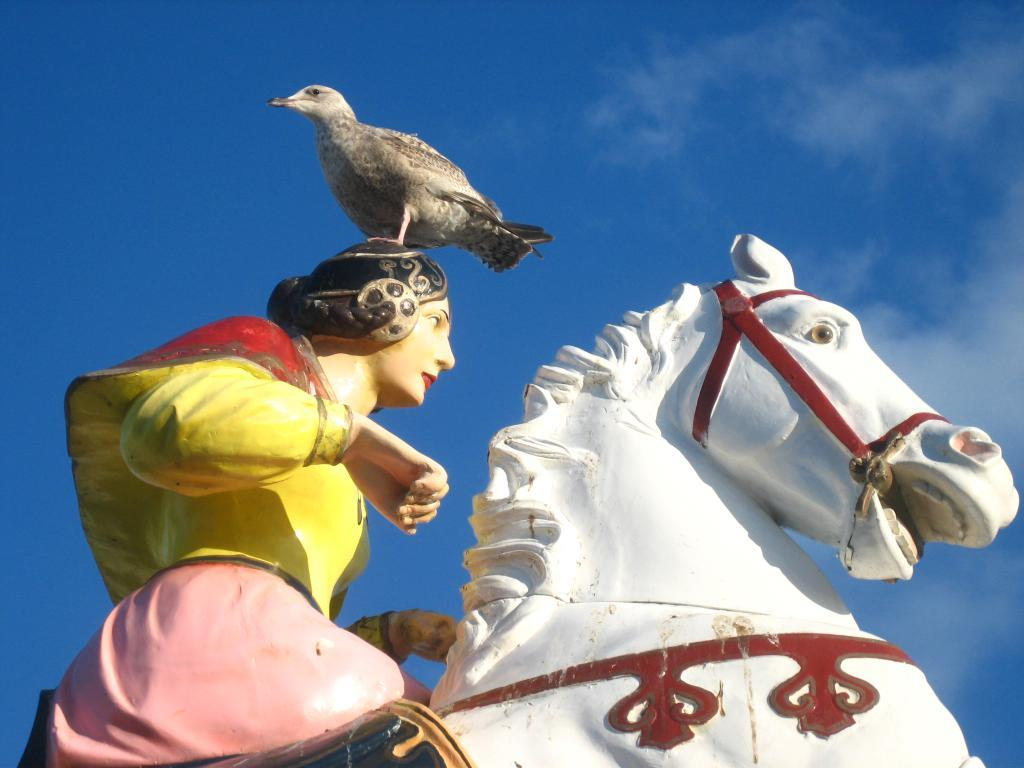What type of statue is featured in the image? There is a human statue in the image. What is the human statue doing in the image? The human statue is sitting on a horse statue. Are there any animals present in the image? Yes, there is a bird in the image. Where is the bird located in relation to the human statue? The bird is sitting on the human statue. What is the condition of the sky in the image? The sky is clear in the image. What type of thread is being used to hold the caption in the image? There is no caption present in the image, so there is no thread being used to hold it. 